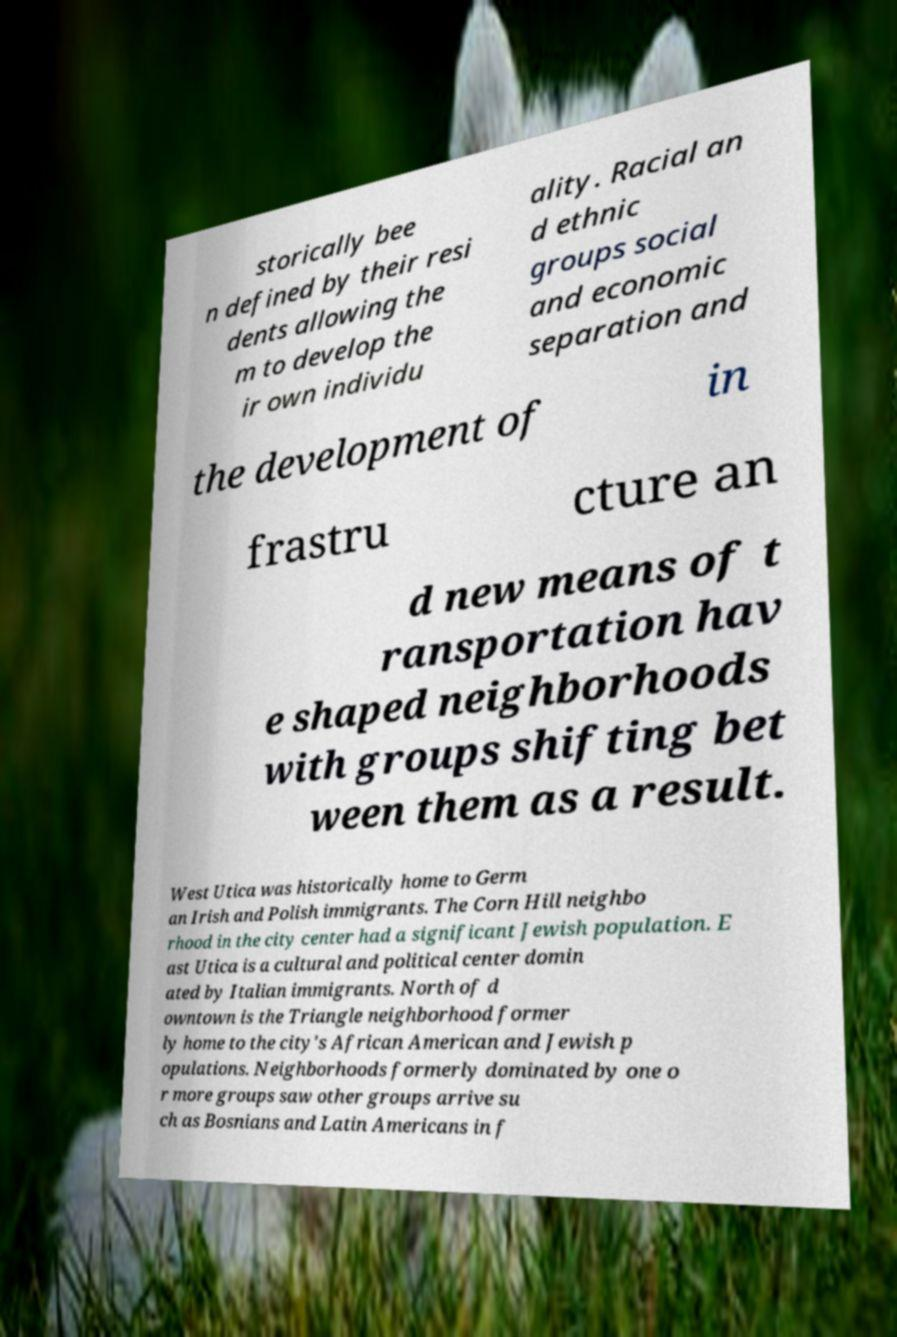Please identify and transcribe the text found in this image. storically bee n defined by their resi dents allowing the m to develop the ir own individu ality. Racial an d ethnic groups social and economic separation and the development of in frastru cture an d new means of t ransportation hav e shaped neighborhoods with groups shifting bet ween them as a result. West Utica was historically home to Germ an Irish and Polish immigrants. The Corn Hill neighbo rhood in the city center had a significant Jewish population. E ast Utica is a cultural and political center domin ated by Italian immigrants. North of d owntown is the Triangle neighborhood former ly home to the city's African American and Jewish p opulations. Neighborhoods formerly dominated by one o r more groups saw other groups arrive su ch as Bosnians and Latin Americans in f 